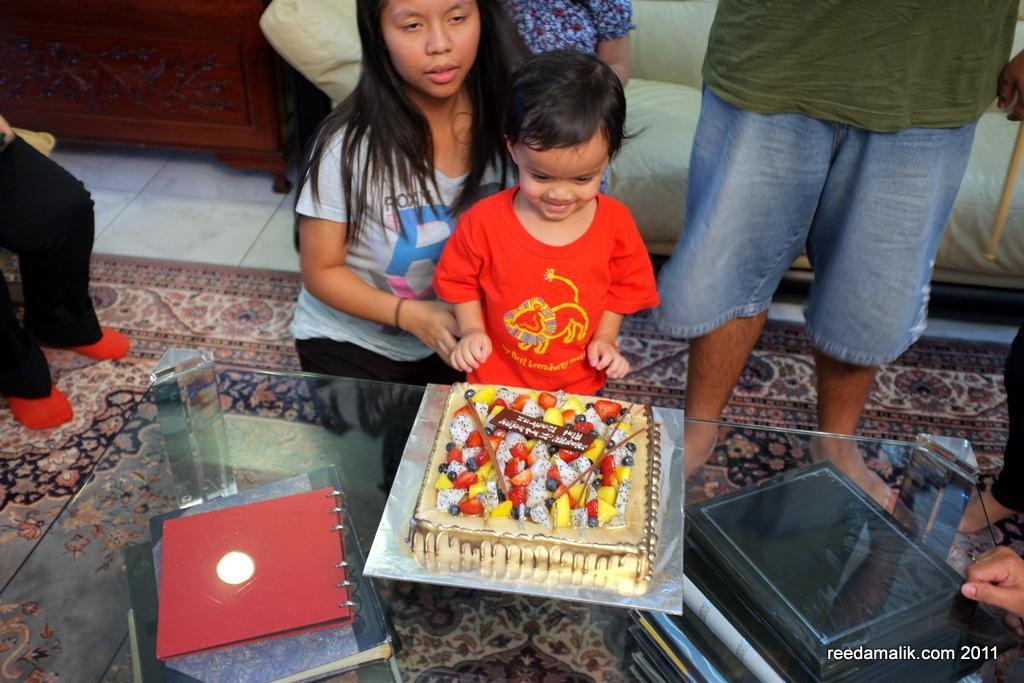Please provide a concise description of this image. In this picture, we see the boy is standing. Beside him, we see a woman. In front of them, we see a glass table on which cake and books are placed. Under the table, we see the books. On the right side, we see a man is standing. Behind him, we see the woman is sitting on the sofa. On the left side, we see a person. In the background, we see a brown table. 